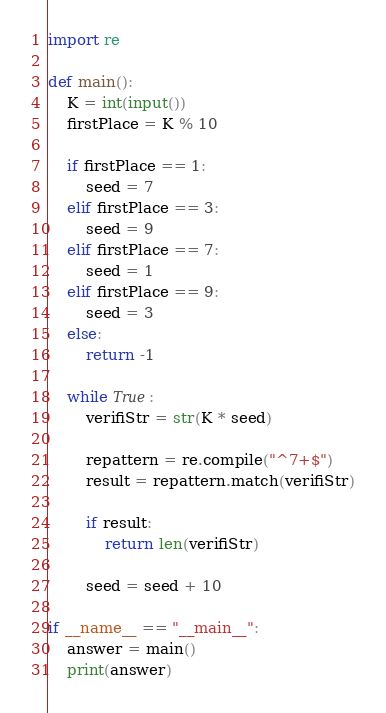Convert code to text. <code><loc_0><loc_0><loc_500><loc_500><_Python_>import re

def main():
    K = int(input())
    firstPlace = K % 10

    if firstPlace == 1:
        seed = 7
    elif firstPlace == 3:
        seed = 9
    elif firstPlace == 7:
        seed = 1
    elif firstPlace == 9:
        seed = 3
    else:
        return -1

    while True:
        verifiStr = str(K * seed)

        repattern = re.compile("^7+$")
        result = repattern.match(verifiStr)

        if result:
            return len(verifiStr)          

        seed = seed + 10

if __name__ == "__main__":
    answer = main()
    print(answer)</code> 